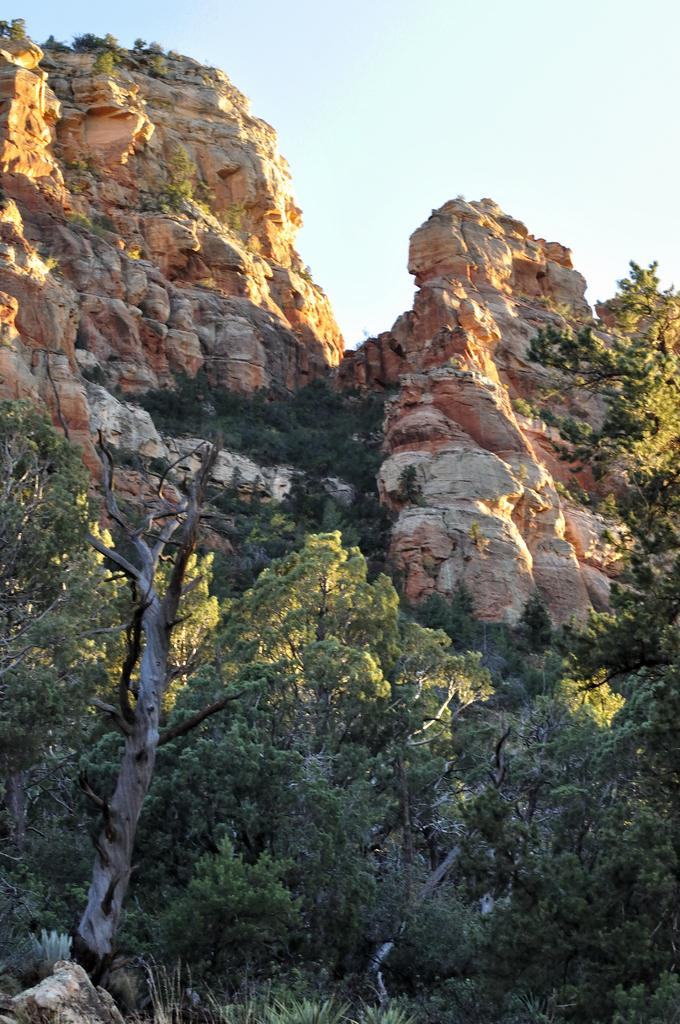What can be seen in the foreground of the picture? There are trees, a rock, and a tree trunk in the foreground of the picture. What is located in the center of the picture? There are trees and a mountain in the center of the picture. What is visible at the top of the picture? The sky is visible at the top of the picture. What type of meat can be seen hanging from the trees in the image? There is no meat present in the image; it features trees, a rock, a tree trunk, a mountain, and the sky. Is there a ball visible in the center of the image? No, there is no ball present in the image. 